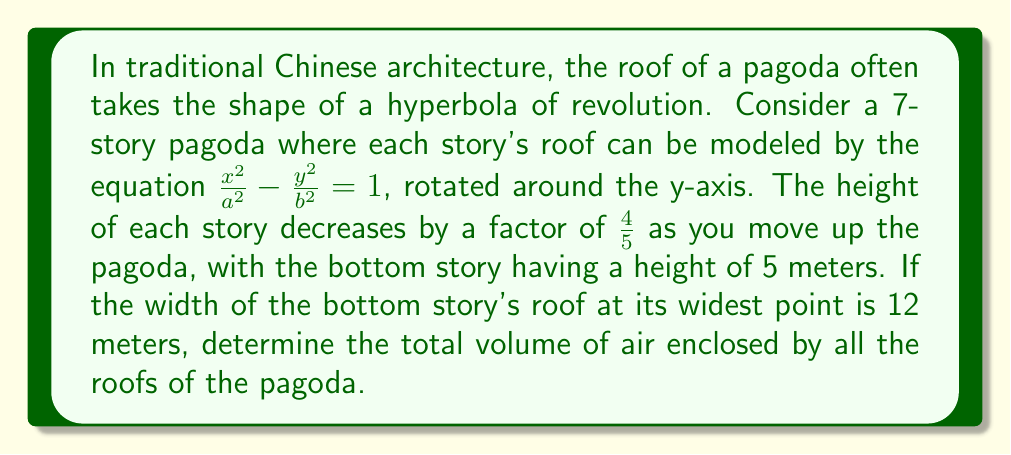Can you solve this math problem? Let's approach this step-by-step:

1) First, we need to find the equations for each story's roof. We know that for a hyperbola $\frac{x^2}{a^2} - \frac{y^2}{b^2} = 1$, $a$ represents half the width at the widest point, and $b$ represents the height.

2) For the bottom story:
   $a_1 = 6$ (half of 12 meters)
   $b_1 = 5$ (given height)

3) For each subsequent story, the width and height will decrease by a factor of $\frac{4}{5}$. So for the $n$th story:
   $a_n = 6 \cdot (\frac{4}{5})^{n-1}$
   $b_n = 5 \cdot (\frac{4}{5})^{n-1}$

4) The volume of a hyperbola of revolution is given by the formula:
   $V = \frac{4\pi}{3}ab^2$

5) So, for each story, the volume is:
   $V_n = \frac{4\pi}{3} \cdot 6 \cdot (\frac{4}{5})^{n-1} \cdot [5 \cdot (\frac{4}{5})^{n-1}]^2$
   $= \frac{4\pi}{3} \cdot 6 \cdot 25 \cdot (\frac{4}{5})^{3n-3}$
   $= 200\pi \cdot (\frac{4}{5})^{3n-3}$

6) The total volume is the sum of volumes for all 7 stories:
   $V_{total} = \sum_{n=1}^7 200\pi \cdot (\frac{4}{5})^{3n-3}$
   $= 200\pi \cdot \sum_{n=1}^7 (\frac{64}{125})^{n-1}$

7) This is a geometric series with first term $a=1$ and common ratio $r=\frac{64}{125}$. The sum of such a series is given by $\frac{a(1-r^n)}{1-r}$ where $n=7$.

8) Applying the formula:
   $V_{total} = 200\pi \cdot \frac{1-(\frac{64}{125})^7}{1-\frac{64}{125}}$
   $= 200\pi \cdot \frac{1-0.1642}{1-0.512}$
   $= 200\pi \cdot 1.7145$
   $\approx 1076.91$ cubic meters
Answer: $200\pi \cdot \frac{1-(\frac{64}{125})^7}{1-\frac{64}{125}} \approx 1076.91$ m³ 